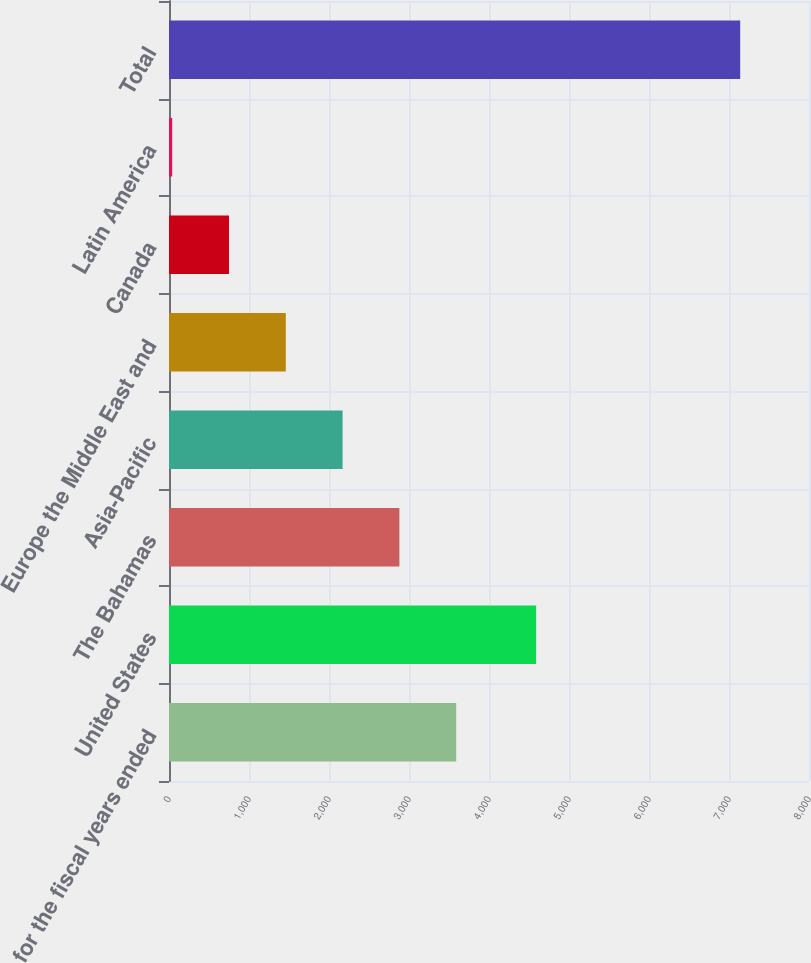<chart> <loc_0><loc_0><loc_500><loc_500><bar_chart><fcel>for the fiscal years ended<fcel>United States<fcel>The Bahamas<fcel>Asia-Pacific<fcel>Europe the Middle East and<fcel>Canada<fcel>Latin America<fcel>Total<nl><fcel>3589.95<fcel>4589.4<fcel>2879.94<fcel>2169.93<fcel>1459.92<fcel>749.91<fcel>39.9<fcel>7140<nl></chart> 